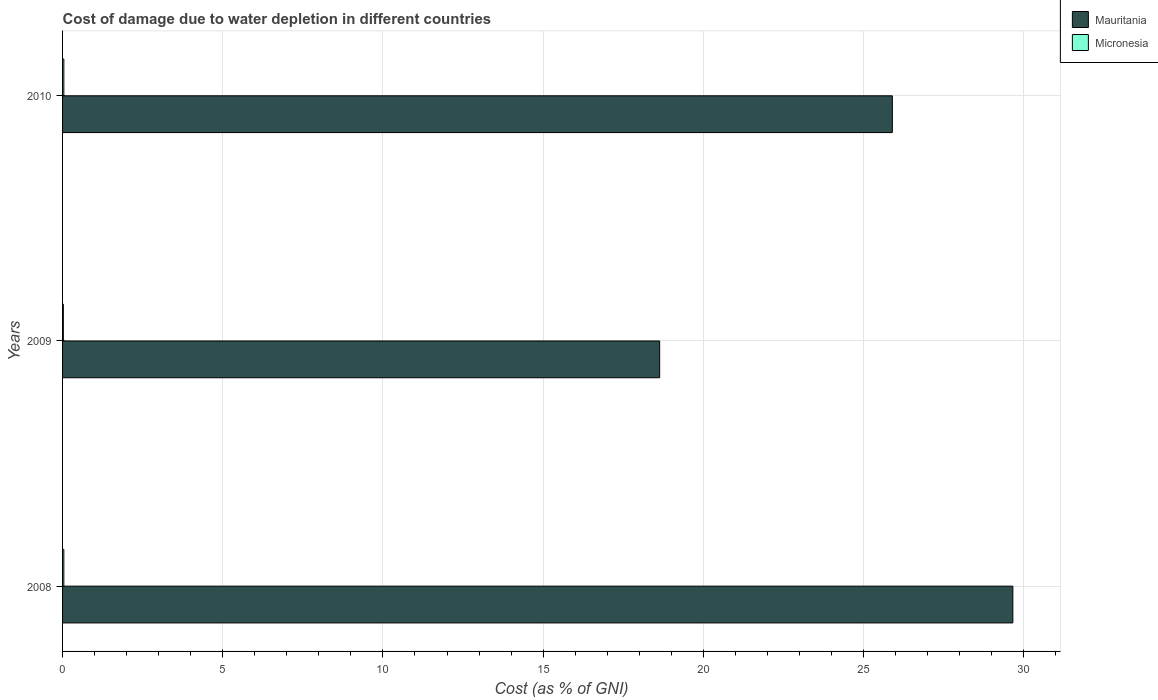Are the number of bars per tick equal to the number of legend labels?
Your answer should be compact. Yes. Are the number of bars on each tick of the Y-axis equal?
Provide a short and direct response. Yes. What is the label of the 2nd group of bars from the top?
Your answer should be compact. 2009. What is the cost of damage caused due to water depletion in Micronesia in 2009?
Give a very brief answer. 0.02. Across all years, what is the maximum cost of damage caused due to water depletion in Micronesia?
Provide a succinct answer. 0.04. Across all years, what is the minimum cost of damage caused due to water depletion in Micronesia?
Your response must be concise. 0.02. In which year was the cost of damage caused due to water depletion in Micronesia maximum?
Offer a terse response. 2010. In which year was the cost of damage caused due to water depletion in Mauritania minimum?
Your response must be concise. 2009. What is the total cost of damage caused due to water depletion in Mauritania in the graph?
Make the answer very short. 74.2. What is the difference between the cost of damage caused due to water depletion in Mauritania in 2008 and that in 2009?
Your answer should be compact. 11.02. What is the difference between the cost of damage caused due to water depletion in Micronesia in 2009 and the cost of damage caused due to water depletion in Mauritania in 2008?
Your answer should be compact. -29.64. What is the average cost of damage caused due to water depletion in Micronesia per year?
Make the answer very short. 0.03. In the year 2010, what is the difference between the cost of damage caused due to water depletion in Micronesia and cost of damage caused due to water depletion in Mauritania?
Provide a short and direct response. -25.86. What is the ratio of the cost of damage caused due to water depletion in Mauritania in 2009 to that in 2010?
Your response must be concise. 0.72. Is the cost of damage caused due to water depletion in Mauritania in 2008 less than that in 2009?
Provide a short and direct response. No. Is the difference between the cost of damage caused due to water depletion in Micronesia in 2009 and 2010 greater than the difference between the cost of damage caused due to water depletion in Mauritania in 2009 and 2010?
Keep it short and to the point. Yes. What is the difference between the highest and the second highest cost of damage caused due to water depletion in Micronesia?
Keep it short and to the point. 0. What is the difference between the highest and the lowest cost of damage caused due to water depletion in Micronesia?
Ensure brevity in your answer.  0.01. In how many years, is the cost of damage caused due to water depletion in Micronesia greater than the average cost of damage caused due to water depletion in Micronesia taken over all years?
Your response must be concise. 2. Is the sum of the cost of damage caused due to water depletion in Mauritania in 2009 and 2010 greater than the maximum cost of damage caused due to water depletion in Micronesia across all years?
Make the answer very short. Yes. What does the 1st bar from the top in 2008 represents?
Keep it short and to the point. Micronesia. What does the 1st bar from the bottom in 2009 represents?
Give a very brief answer. Mauritania. What is the difference between two consecutive major ticks on the X-axis?
Your answer should be compact. 5. Does the graph contain grids?
Ensure brevity in your answer.  Yes. Where does the legend appear in the graph?
Your response must be concise. Top right. How many legend labels are there?
Offer a very short reply. 2. How are the legend labels stacked?
Provide a succinct answer. Vertical. What is the title of the graph?
Give a very brief answer. Cost of damage due to water depletion in different countries. Does "Kazakhstan" appear as one of the legend labels in the graph?
Give a very brief answer. No. What is the label or title of the X-axis?
Offer a terse response. Cost (as % of GNI). What is the label or title of the Y-axis?
Your response must be concise. Years. What is the Cost (as % of GNI) of Mauritania in 2008?
Offer a very short reply. 29.66. What is the Cost (as % of GNI) in Micronesia in 2008?
Your answer should be very brief. 0.04. What is the Cost (as % of GNI) of Mauritania in 2009?
Ensure brevity in your answer.  18.64. What is the Cost (as % of GNI) of Micronesia in 2009?
Your answer should be compact. 0.02. What is the Cost (as % of GNI) in Mauritania in 2010?
Give a very brief answer. 25.9. What is the Cost (as % of GNI) of Micronesia in 2010?
Give a very brief answer. 0.04. Across all years, what is the maximum Cost (as % of GNI) in Mauritania?
Your response must be concise. 29.66. Across all years, what is the maximum Cost (as % of GNI) of Micronesia?
Give a very brief answer. 0.04. Across all years, what is the minimum Cost (as % of GNI) of Mauritania?
Your response must be concise. 18.64. Across all years, what is the minimum Cost (as % of GNI) in Micronesia?
Your response must be concise. 0.02. What is the total Cost (as % of GNI) of Mauritania in the graph?
Your answer should be compact. 74.2. What is the total Cost (as % of GNI) in Micronesia in the graph?
Make the answer very short. 0.1. What is the difference between the Cost (as % of GNI) in Mauritania in 2008 and that in 2009?
Offer a very short reply. 11.02. What is the difference between the Cost (as % of GNI) in Micronesia in 2008 and that in 2009?
Offer a very short reply. 0.01. What is the difference between the Cost (as % of GNI) in Mauritania in 2008 and that in 2010?
Your response must be concise. 3.76. What is the difference between the Cost (as % of GNI) of Micronesia in 2008 and that in 2010?
Give a very brief answer. -0. What is the difference between the Cost (as % of GNI) in Mauritania in 2009 and that in 2010?
Your answer should be very brief. -7.26. What is the difference between the Cost (as % of GNI) in Micronesia in 2009 and that in 2010?
Your response must be concise. -0.01. What is the difference between the Cost (as % of GNI) in Mauritania in 2008 and the Cost (as % of GNI) in Micronesia in 2009?
Provide a succinct answer. 29.64. What is the difference between the Cost (as % of GNI) in Mauritania in 2008 and the Cost (as % of GNI) in Micronesia in 2010?
Your answer should be compact. 29.62. What is the difference between the Cost (as % of GNI) in Mauritania in 2009 and the Cost (as % of GNI) in Micronesia in 2010?
Keep it short and to the point. 18.6. What is the average Cost (as % of GNI) of Mauritania per year?
Your answer should be very brief. 24.73. What is the average Cost (as % of GNI) in Micronesia per year?
Keep it short and to the point. 0.03. In the year 2008, what is the difference between the Cost (as % of GNI) in Mauritania and Cost (as % of GNI) in Micronesia?
Make the answer very short. 29.62. In the year 2009, what is the difference between the Cost (as % of GNI) of Mauritania and Cost (as % of GNI) of Micronesia?
Ensure brevity in your answer.  18.61. In the year 2010, what is the difference between the Cost (as % of GNI) in Mauritania and Cost (as % of GNI) in Micronesia?
Ensure brevity in your answer.  25.86. What is the ratio of the Cost (as % of GNI) of Mauritania in 2008 to that in 2009?
Your answer should be compact. 1.59. What is the ratio of the Cost (as % of GNI) of Micronesia in 2008 to that in 2009?
Your answer should be compact. 1.58. What is the ratio of the Cost (as % of GNI) in Mauritania in 2008 to that in 2010?
Your response must be concise. 1.15. What is the ratio of the Cost (as % of GNI) in Micronesia in 2008 to that in 2010?
Make the answer very short. 0.98. What is the ratio of the Cost (as % of GNI) of Mauritania in 2009 to that in 2010?
Your answer should be compact. 0.72. What is the ratio of the Cost (as % of GNI) in Micronesia in 2009 to that in 2010?
Offer a very short reply. 0.62. What is the difference between the highest and the second highest Cost (as % of GNI) in Mauritania?
Give a very brief answer. 3.76. What is the difference between the highest and the second highest Cost (as % of GNI) of Micronesia?
Keep it short and to the point. 0. What is the difference between the highest and the lowest Cost (as % of GNI) of Mauritania?
Keep it short and to the point. 11.02. What is the difference between the highest and the lowest Cost (as % of GNI) in Micronesia?
Keep it short and to the point. 0.01. 